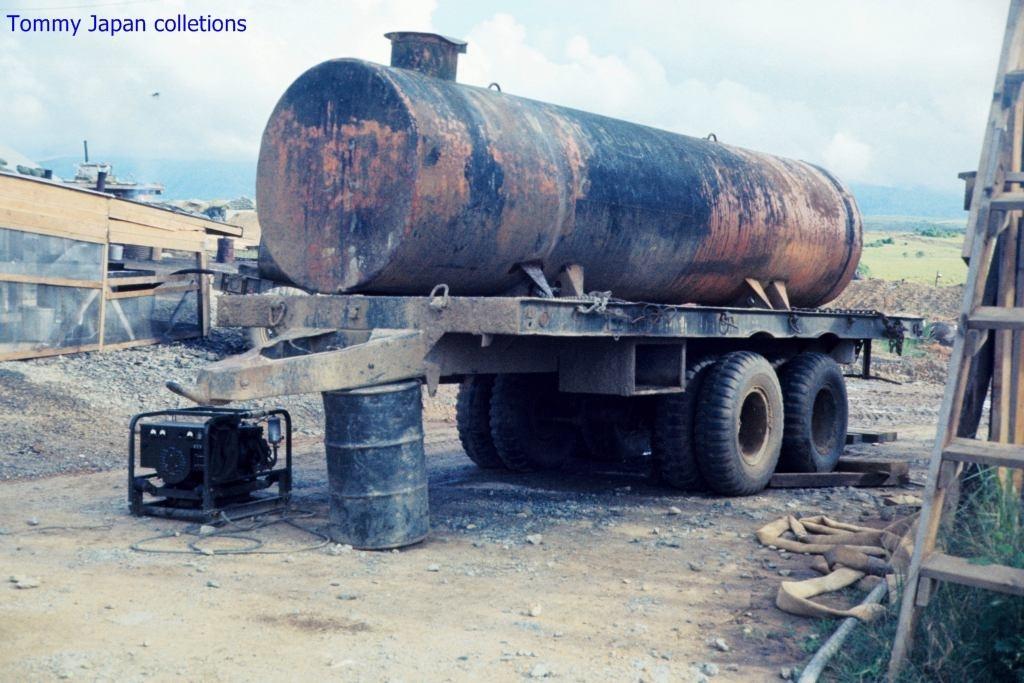Please provide a concise description of this image. In this picture I can see the ground, on which I can see a tanker and I see a barrel and an equipment near to it and I see few things on both the sides. In the background I can see the sky. On the top left corner of this picture I can see the watermark. 